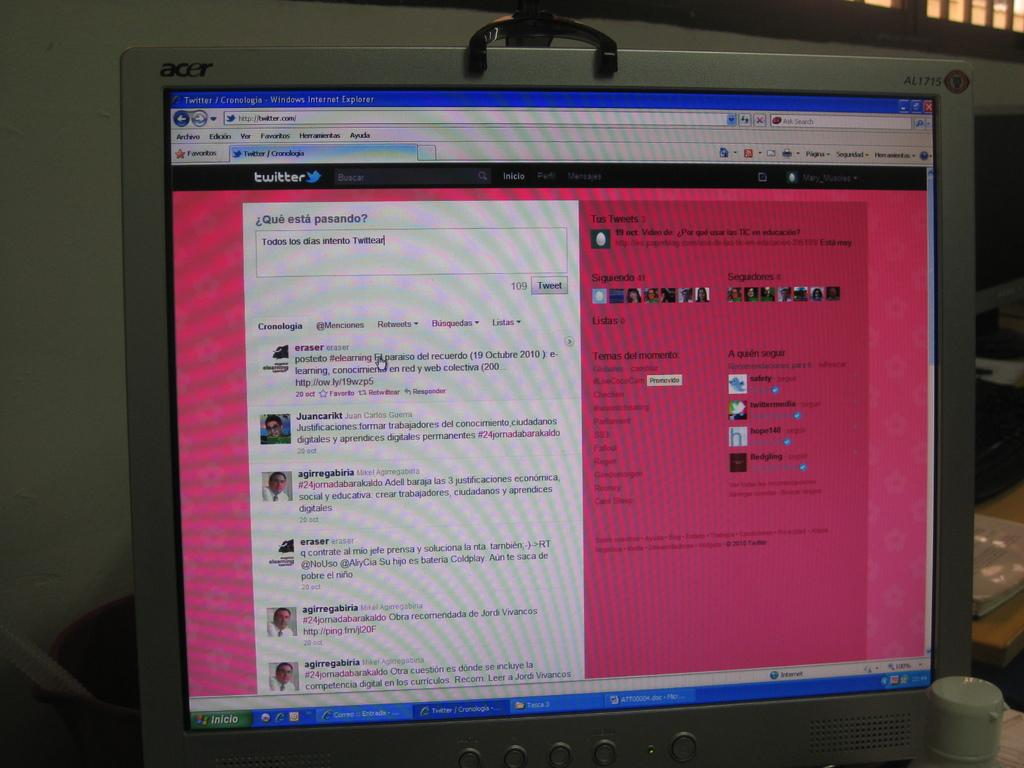<image>
Present a compact description of the photo's key features. A computer monitor with Twitter on the screen 